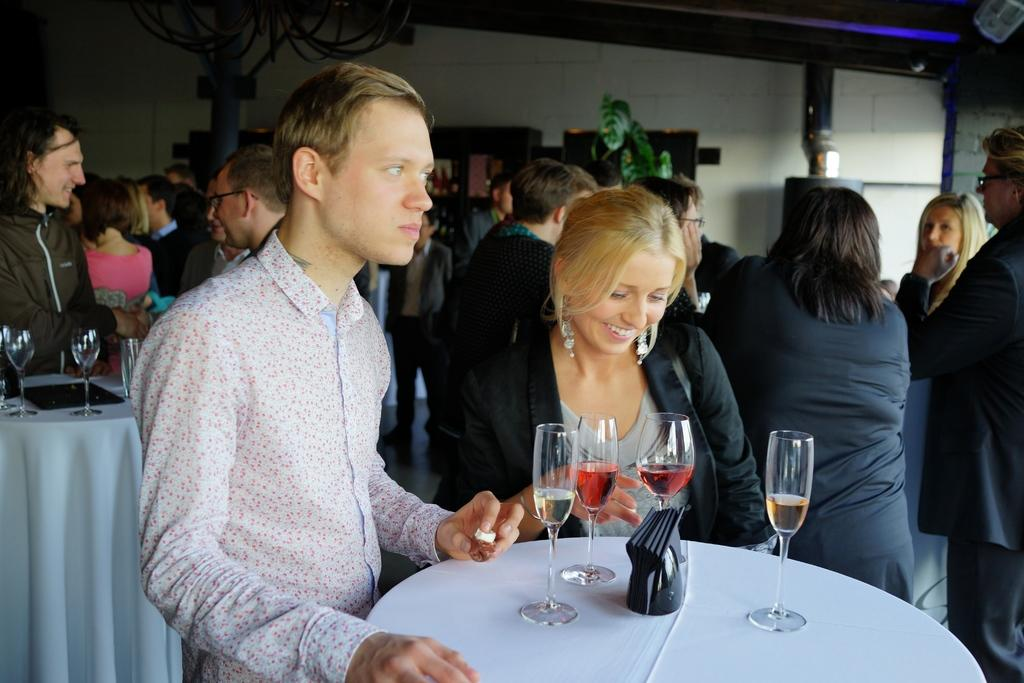How many people are in the group that is visible in the image? There is a group of people standing in the image, but the exact number cannot be determined from the provided facts. What is on the table in the image? There are glasses on a table in the image. What type of vegetation is present in the image? There is a plant in the image. What is providing illumination in the image? There is a light in the image. What type of sack is being used to transport the car in the image? There is no sack or car present in the image. How many carts are visible in the image? There is no mention of carts in the provided facts, so it cannot be determined if any are present in the image. 